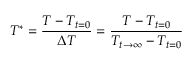Convert formula to latex. <formula><loc_0><loc_0><loc_500><loc_500>T ^ { * } = \frac { T - T _ { t = 0 } } { \Delta T } = \frac { T - T _ { t = 0 } } { T _ { t \rightarrow \infty } - T _ { t = 0 } }</formula> 